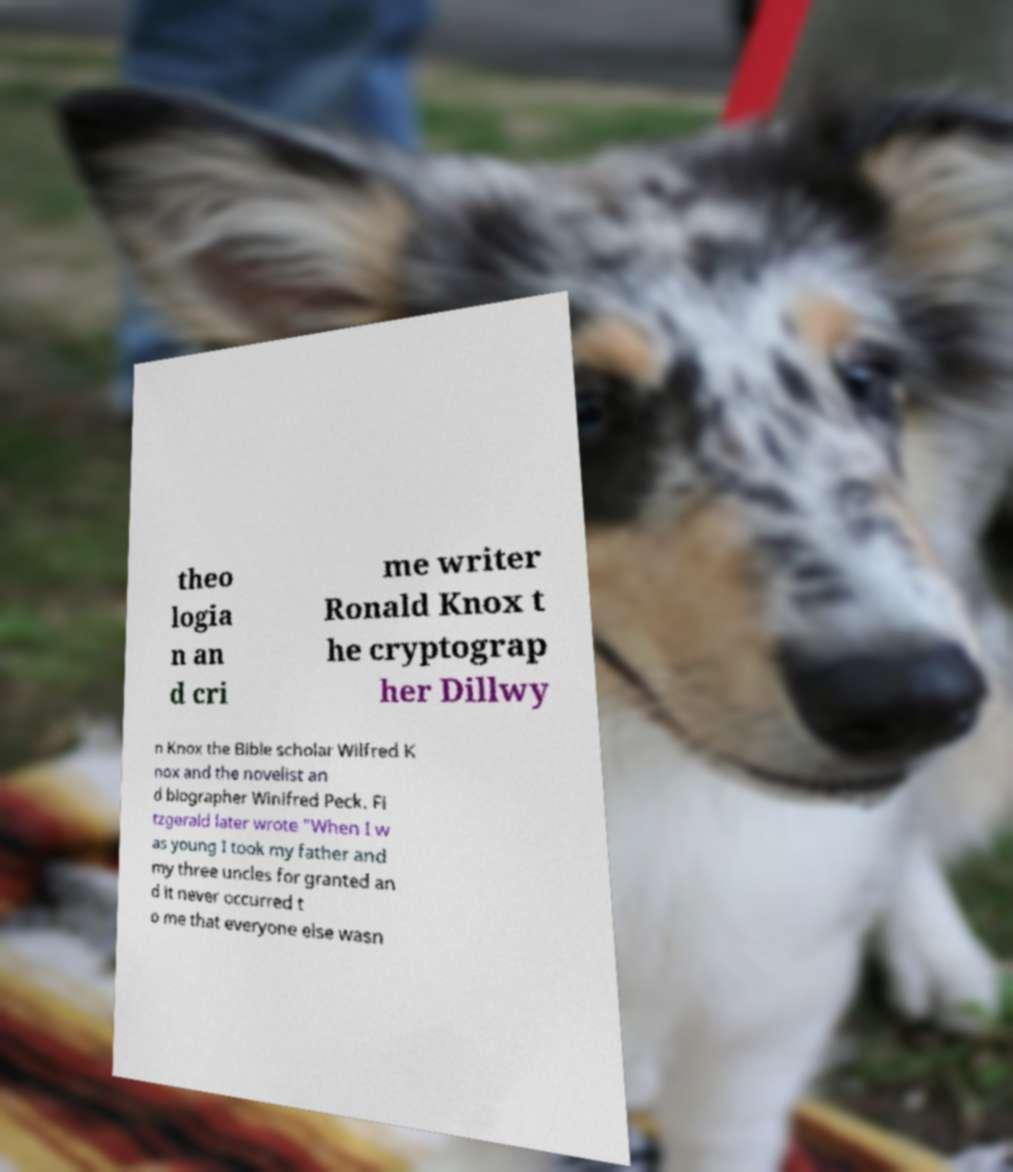Can you accurately transcribe the text from the provided image for me? theo logia n an d cri me writer Ronald Knox t he cryptograp her Dillwy n Knox the Bible scholar Wilfred K nox and the novelist an d biographer Winifred Peck. Fi tzgerald later wrote "When I w as young I took my father and my three uncles for granted an d it never occurred t o me that everyone else wasn 